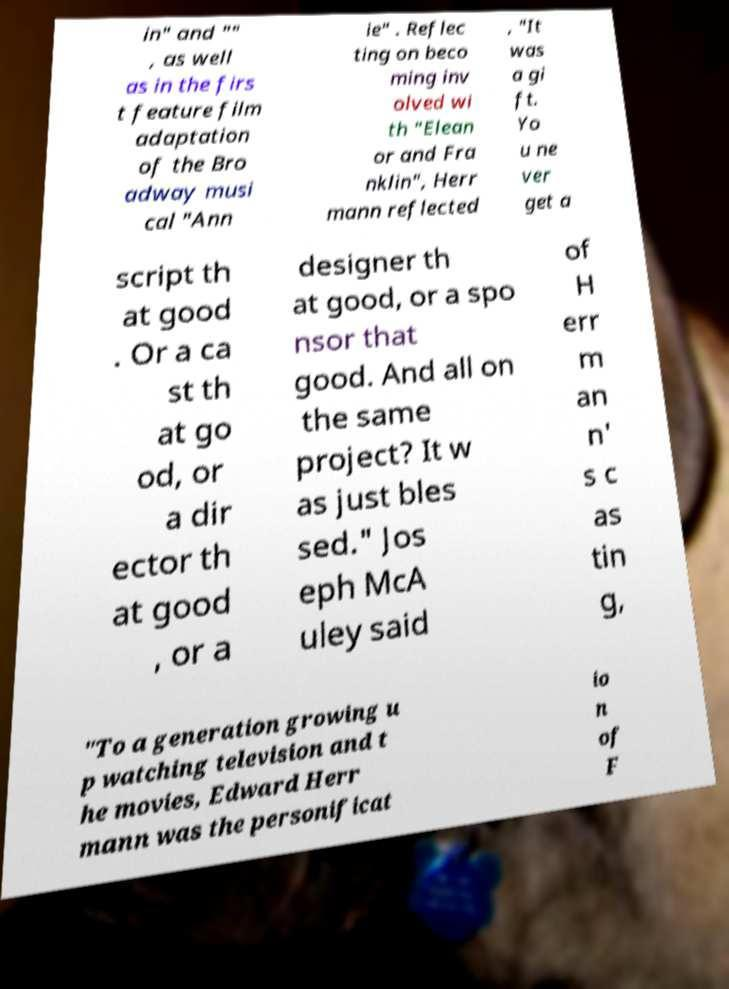What messages or text are displayed in this image? I need them in a readable, typed format. in" and "" , as well as in the firs t feature film adaptation of the Bro adway musi cal "Ann ie" . Reflec ting on beco ming inv olved wi th "Elean or and Fra nklin", Herr mann reflected , "It was a gi ft. Yo u ne ver get a script th at good . Or a ca st th at go od, or a dir ector th at good , or a designer th at good, or a spo nsor that good. And all on the same project? It w as just bles sed." Jos eph McA uley said of H err m an n' s c as tin g, "To a generation growing u p watching television and t he movies, Edward Herr mann was the personificat io n of F 